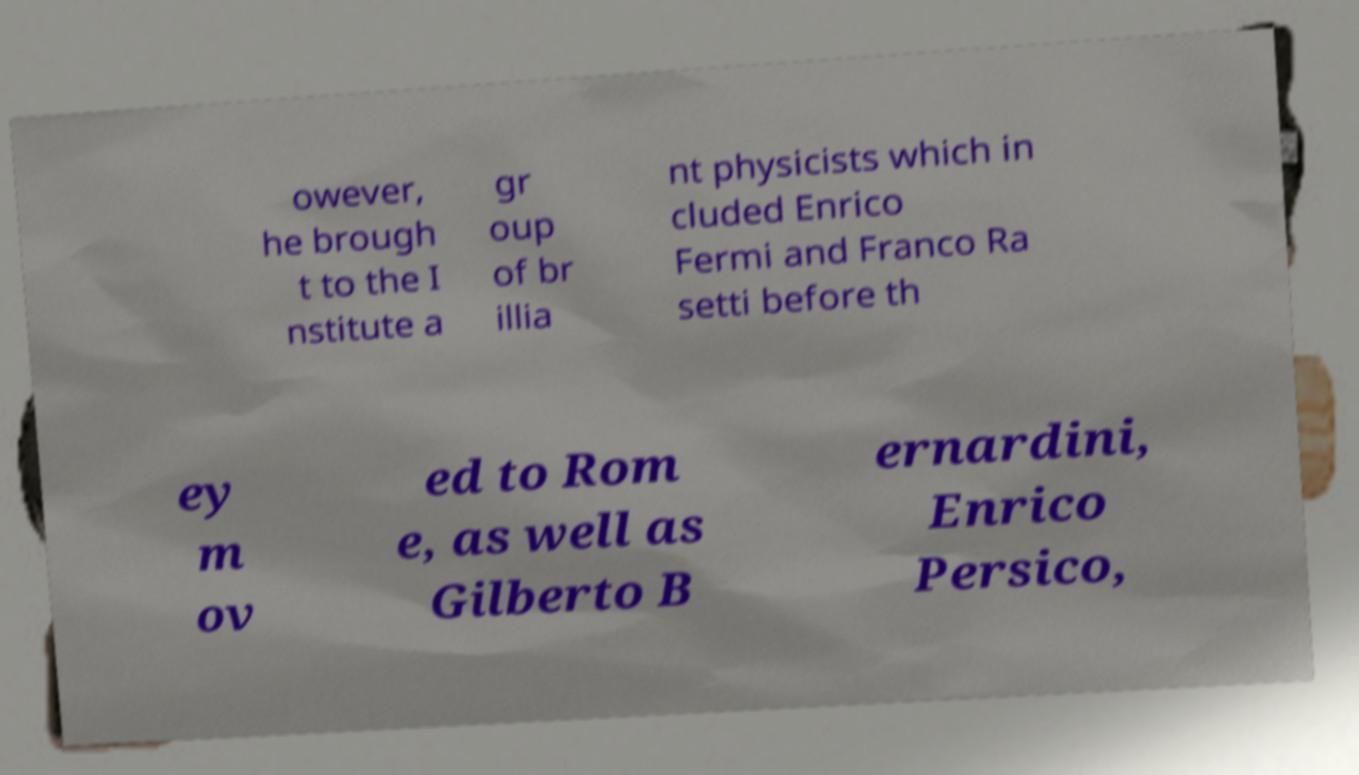Can you accurately transcribe the text from the provided image for me? owever, he brough t to the I nstitute a gr oup of br illia nt physicists which in cluded Enrico Fermi and Franco Ra setti before th ey m ov ed to Rom e, as well as Gilberto B ernardini, Enrico Persico, 